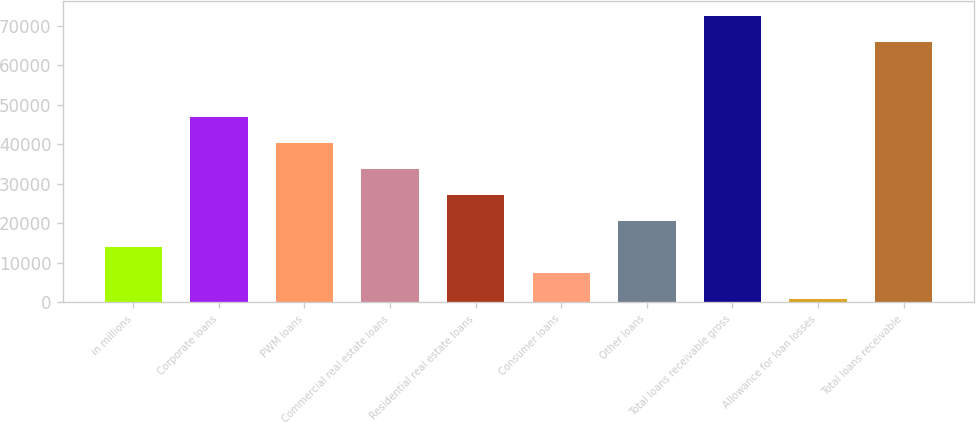<chart> <loc_0><loc_0><loc_500><loc_500><bar_chart><fcel>in millions<fcel>Corporate loans<fcel>PWM loans<fcel>Commercial real estate loans<fcel>Residential real estate loans<fcel>Consumer loans<fcel>Other loans<fcel>Total loans receivable gross<fcel>Allowance for loan losses<fcel>Total loans receivable<nl><fcel>13989.6<fcel>46956.1<fcel>40362.8<fcel>33769.5<fcel>27176.2<fcel>7396.3<fcel>20582.9<fcel>72526.3<fcel>803<fcel>65933<nl></chart> 